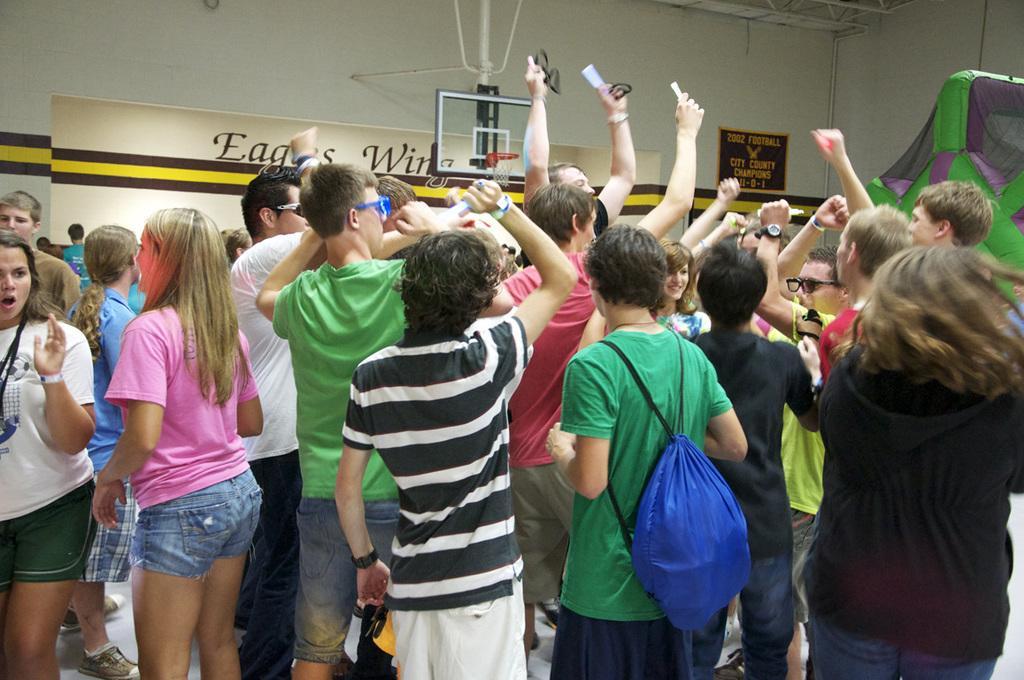Please provide a concise description of this image. In this image there are group of people standing together, in which some of them are holding cameras and capturing them. 